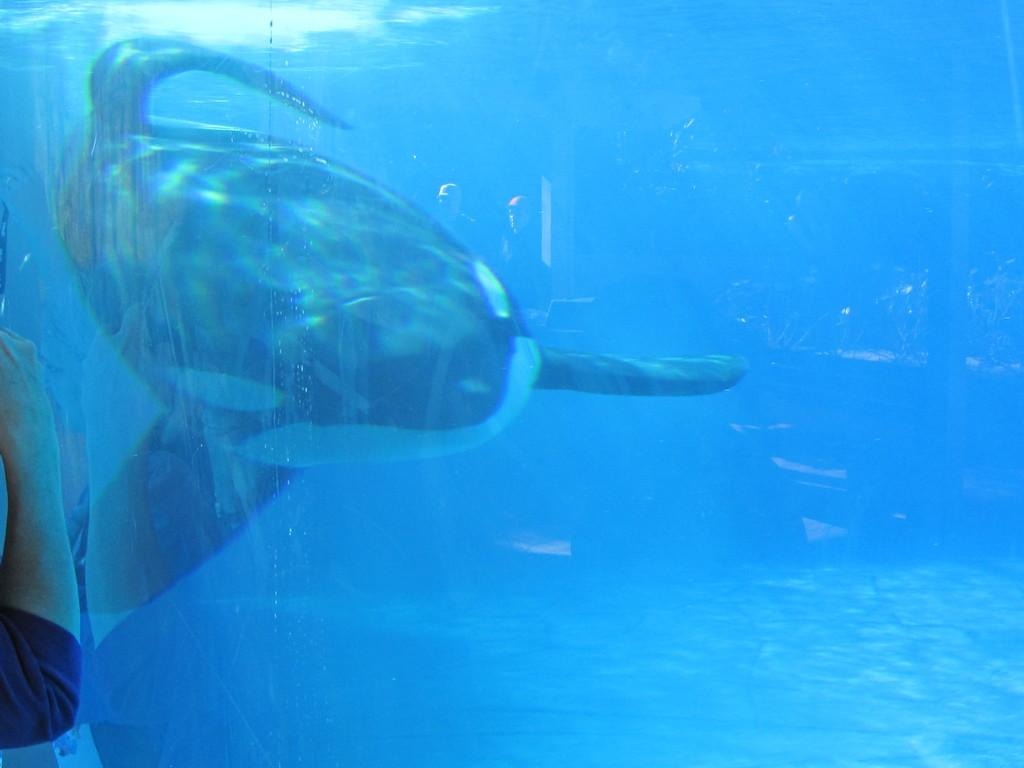What is in the water in the image? There is a fish in the water in the image. Can you describe the people in the background of the image? There are two persons in the background of the image. What type of seed is being planted by the daughter in the image? There is no daughter or seed present in the image. 